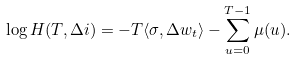<formula> <loc_0><loc_0><loc_500><loc_500>\log H ( T , \Delta i ) = - T \langle \sigma , \Delta w _ { t } \rangle - \sum _ { u = 0 } ^ { T - 1 } \mu ( u ) .</formula> 